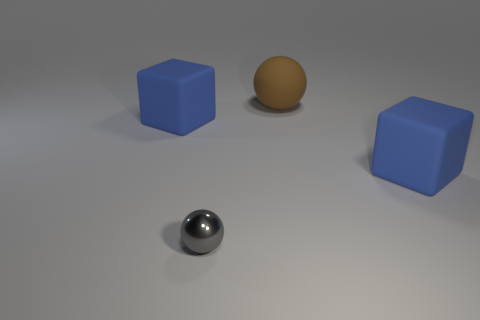Add 3 large brown rubber spheres. How many objects exist? 7 Subtract all brown spheres. How many spheres are left? 1 Subtract 2 spheres. How many spheres are left? 0 Subtract 0 cyan balls. How many objects are left? 4 Subtract all red spheres. Subtract all blue cylinders. How many spheres are left? 2 Subtract all gray cubes. How many gray balls are left? 1 Subtract all purple rubber cylinders. Subtract all large brown rubber things. How many objects are left? 3 Add 4 metallic spheres. How many metallic spheres are left? 5 Add 2 large blocks. How many large blocks exist? 4 